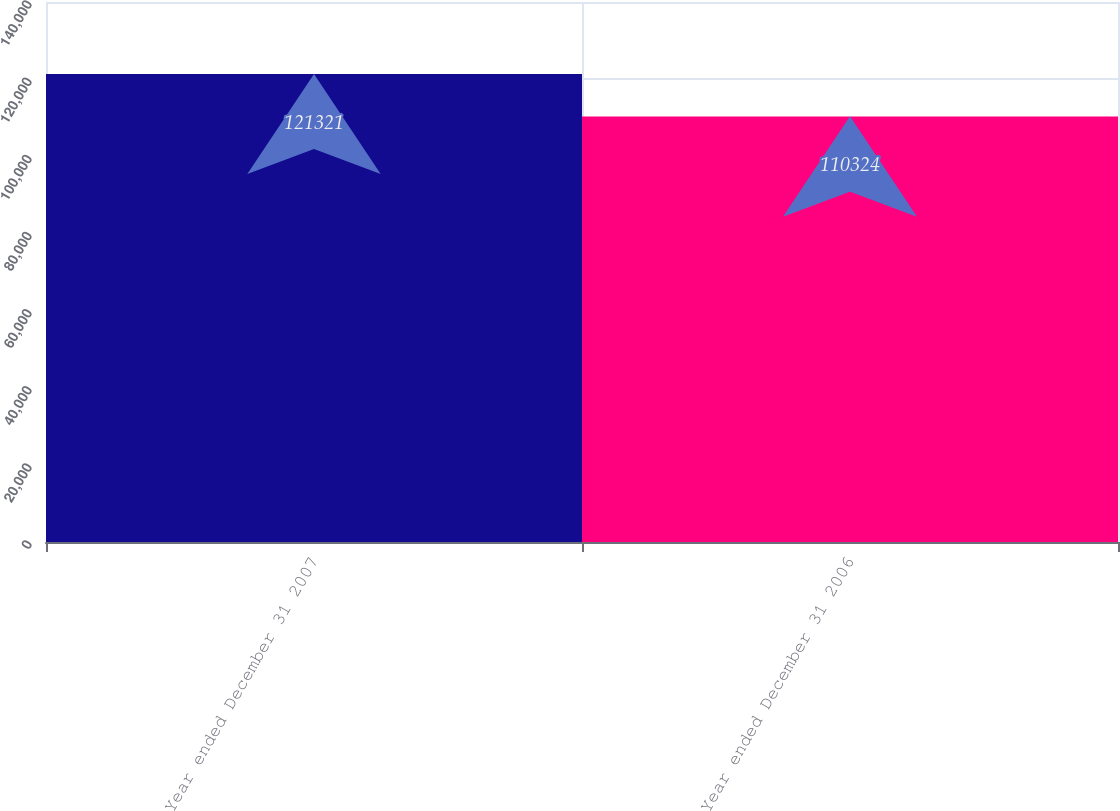Convert chart to OTSL. <chart><loc_0><loc_0><loc_500><loc_500><bar_chart><fcel>Year ended December 31 2007<fcel>Year ended December 31 2006<nl><fcel>121321<fcel>110324<nl></chart> 